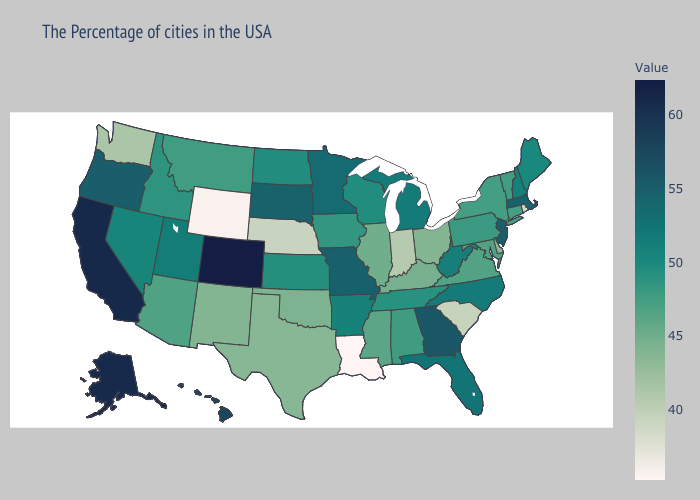Does Nevada have the lowest value in the USA?
Be succinct. No. Among the states that border Missouri , does Tennessee have the highest value?
Be succinct. No. Does Rhode Island have the lowest value in the Northeast?
Write a very short answer. Yes. Which states hav the highest value in the Northeast?
Keep it brief. New Jersey. Which states have the highest value in the USA?
Answer briefly. Colorado. Is the legend a continuous bar?
Answer briefly. Yes. Among the states that border Colorado , which have the lowest value?
Keep it brief. Wyoming. 